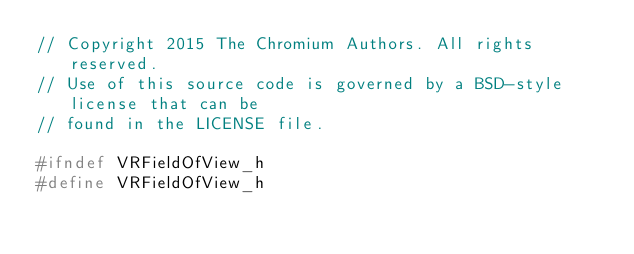<code> <loc_0><loc_0><loc_500><loc_500><_C_>// Copyright 2015 The Chromium Authors. All rights reserved.
// Use of this source code is governed by a BSD-style license that can be
// found in the LICENSE file.

#ifndef VRFieldOfView_h
#define VRFieldOfView_h
</code> 